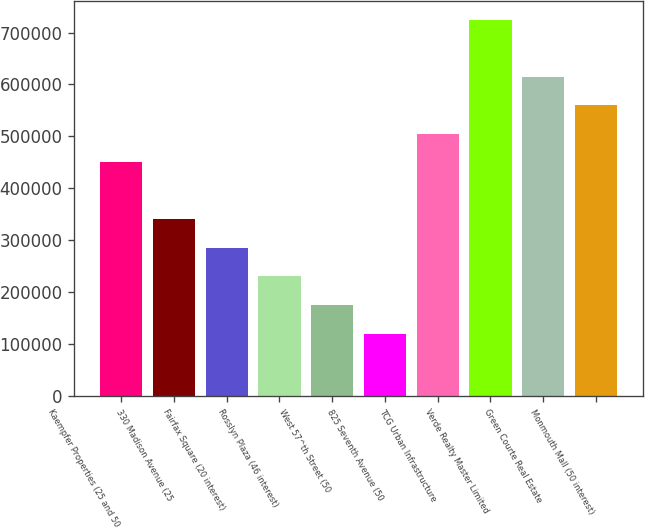Convert chart to OTSL. <chart><loc_0><loc_0><loc_500><loc_500><bar_chart><fcel>Kaempfer Properties (25 and 50<fcel>330 Madison Avenue (25<fcel>Fairfax Square (20 interest)<fcel>Rosslyn Plaza (46 interest)<fcel>West 57^th Street (50<fcel>825 Seventh Avenue (50<fcel>TCG Urban Infrastructure<fcel>Verde Realty Master Limited<fcel>Green Courte Real Estate<fcel>Monmouth Mall (50 interest)<nl><fcel>449912<fcel>339984<fcel>285020<fcel>230056<fcel>175092<fcel>120128<fcel>504876<fcel>724732<fcel>614804<fcel>559840<nl></chart> 